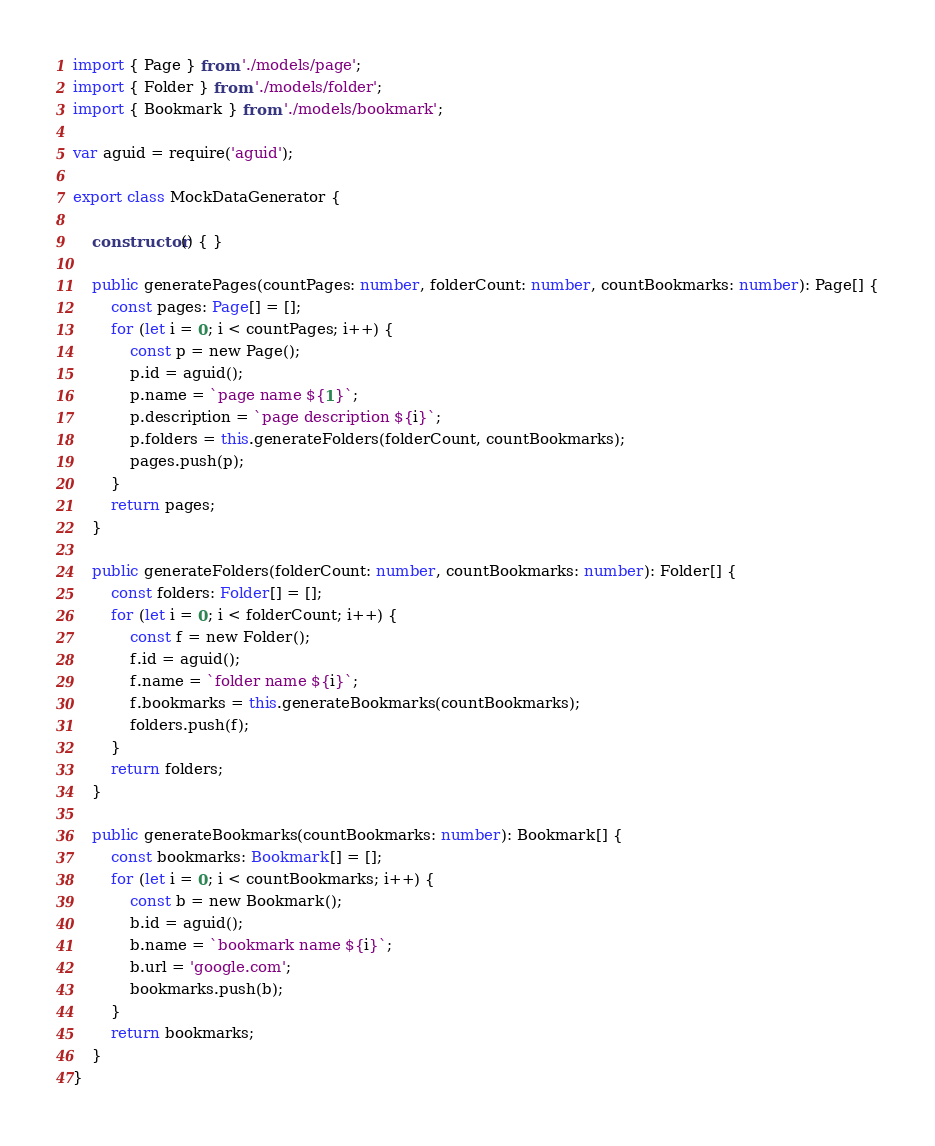<code> <loc_0><loc_0><loc_500><loc_500><_TypeScript_>import { Page } from './models/page';
import { Folder } from './models/folder';
import { Bookmark } from './models/bookmark';

var aguid = require('aguid');

export class MockDataGenerator {

    constructor() { }

    public generatePages(countPages: number, folderCount: number, countBookmarks: number): Page[] {
        const pages: Page[] = [];
        for (let i = 0; i < countPages; i++) {
            const p = new Page();
            p.id = aguid();
            p.name = `page name ${1}`;
            p.description = `page description ${i}`;
            p.folders = this.generateFolders(folderCount, countBookmarks);
            pages.push(p);
        }
        return pages;
    }

    public generateFolders(folderCount: number, countBookmarks: number): Folder[] {
        const folders: Folder[] = [];
        for (let i = 0; i < folderCount; i++) {
            const f = new Folder();
            f.id = aguid();
            f.name = `folder name ${i}`;
            f.bookmarks = this.generateBookmarks(countBookmarks);
            folders.push(f);
        }
        return folders;
    }
    
    public generateBookmarks(countBookmarks: number): Bookmark[] {
        const bookmarks: Bookmark[] = [];
        for (let i = 0; i < countBookmarks; i++) {
            const b = new Bookmark();
            b.id = aguid();
            b.name = `bookmark name ${i}`;
            b.url = 'google.com';
            bookmarks.push(b);
        }
        return bookmarks;
    }
}</code> 